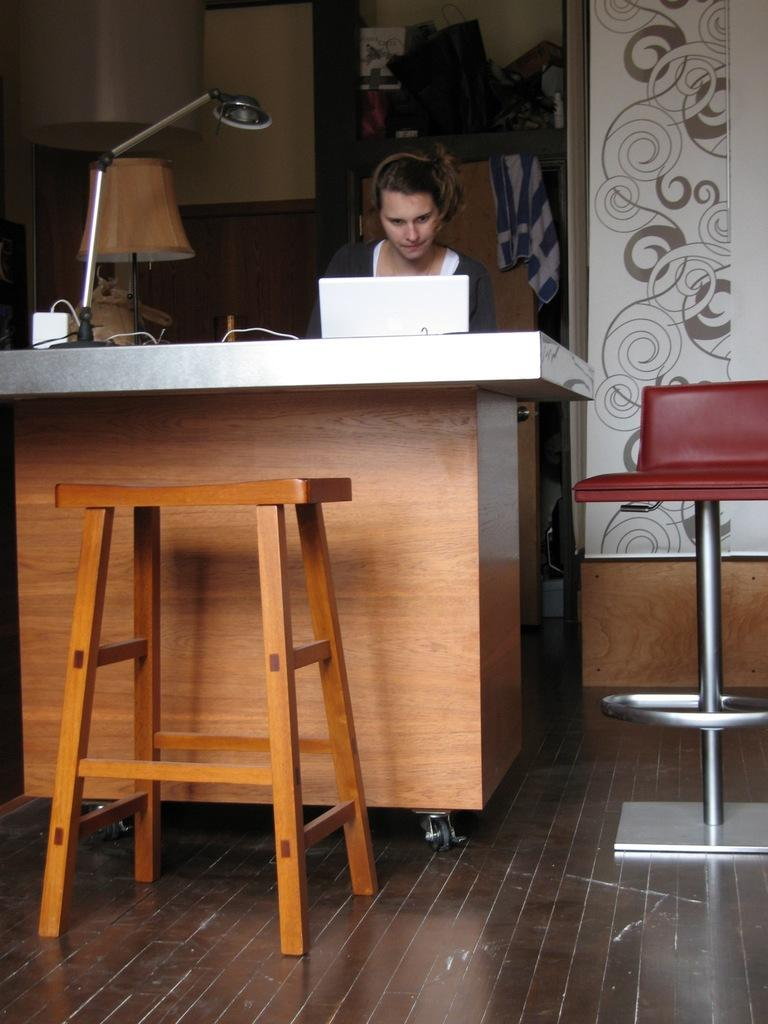Who is present in the image? There is a woman in the image. What is the woman doing in the image? The woman is sitting in a chair and operating a laptop. What objects can be seen on the table in the image? There are lamps, cables, a laptop, and boxes on the table. What is the purpose of the cables on the table? The cables on the table are likely used to connect and power the laptop and other devices. What is visible on the wall in the image? There is no specific detail about the wall in the image, but a wall is visible. What type of ball is being used as an example of insurance in the image? There is no ball or reference to insurance in the image; it features a woman sitting in a chair and operating a laptop. 